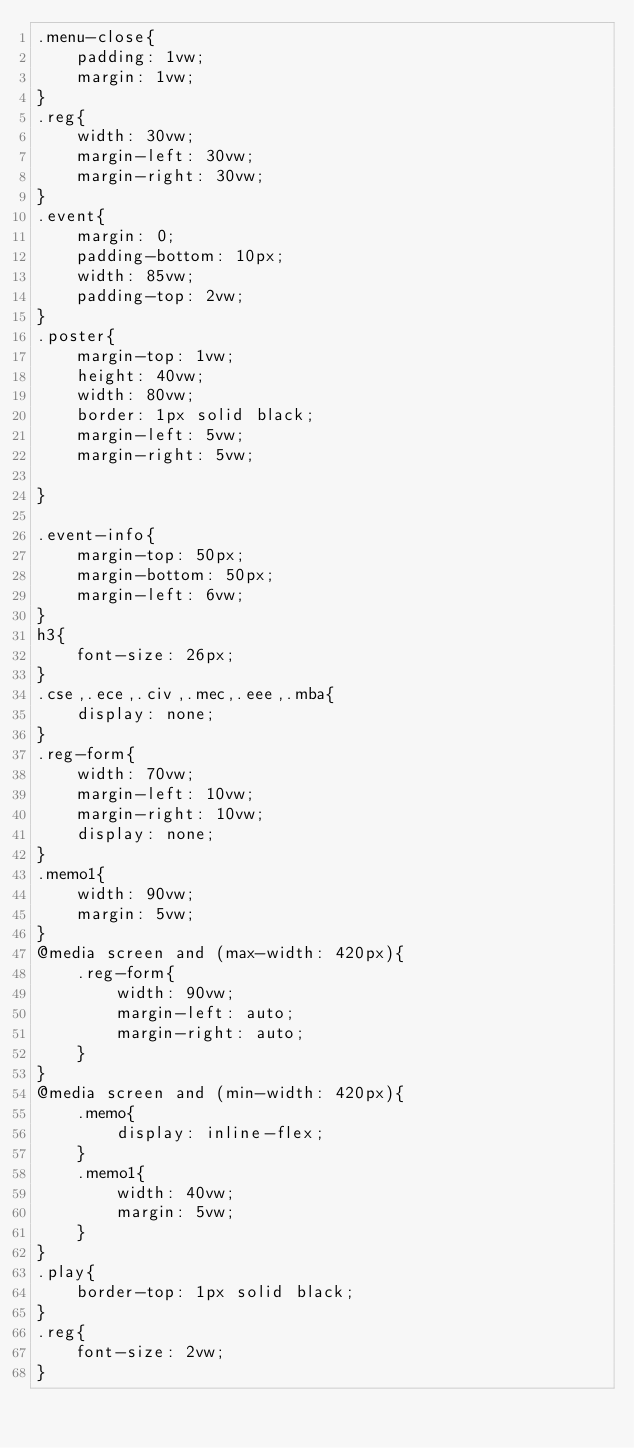Convert code to text. <code><loc_0><loc_0><loc_500><loc_500><_CSS_>.menu-close{
    padding: 1vw;
    margin: 1vw;
}
.reg{
    width: 30vw;
    margin-left: 30vw;
    margin-right: 30vw;
}
.event{
    margin: 0;
    padding-bottom: 10px; 
    width: 85vw;
    padding-top: 2vw;
}
.poster{
    margin-top: 1vw;
    height: 40vw;
    width: 80vw;
    border: 1px solid black;
    margin-left: 5vw;
    margin-right: 5vw;

}

.event-info{
    margin-top: 50px;
    margin-bottom: 50px;
    margin-left: 6vw;
}
h3{
    font-size: 26px;
}
.cse,.ece,.civ,.mec,.eee,.mba{
    display: none;
}
.reg-form{
    width: 70vw;
    margin-left: 10vw;
    margin-right: 10vw; 
    display: none;
}
.memo1{
    width: 90vw;
    margin: 5vw;
}
@media screen and (max-width: 420px){
    .reg-form{
        width: 90vw;
        margin-left: auto;
        margin-right: auto;
    }
}
@media screen and (min-width: 420px){
    .memo{
        display: inline-flex;
    }
    .memo1{
        width: 40vw;
        margin: 5vw;
    }
}
.play{
    border-top: 1px solid black;
}
.reg{
    font-size: 2vw;
}</code> 